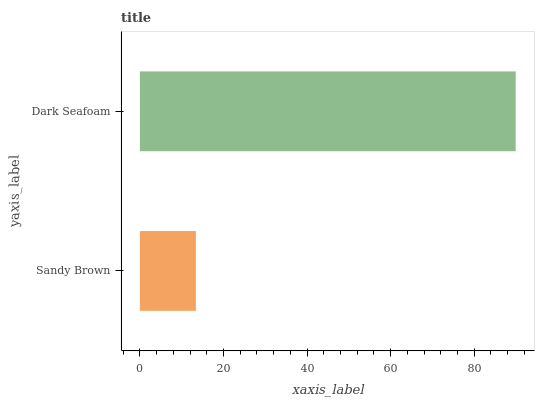Is Sandy Brown the minimum?
Answer yes or no. Yes. Is Dark Seafoam the maximum?
Answer yes or no. Yes. Is Dark Seafoam the minimum?
Answer yes or no. No. Is Dark Seafoam greater than Sandy Brown?
Answer yes or no. Yes. Is Sandy Brown less than Dark Seafoam?
Answer yes or no. Yes. Is Sandy Brown greater than Dark Seafoam?
Answer yes or no. No. Is Dark Seafoam less than Sandy Brown?
Answer yes or no. No. Is Dark Seafoam the high median?
Answer yes or no. Yes. Is Sandy Brown the low median?
Answer yes or no. Yes. Is Sandy Brown the high median?
Answer yes or no. No. Is Dark Seafoam the low median?
Answer yes or no. No. 